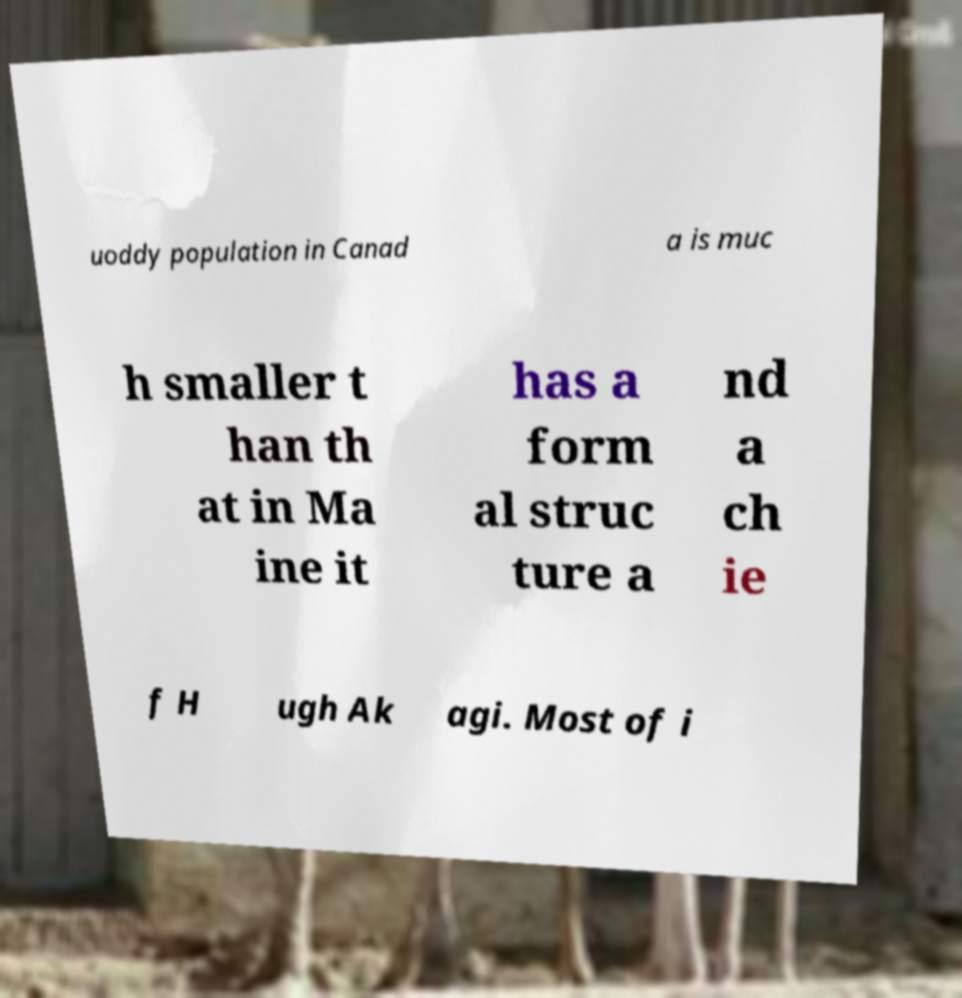I need the written content from this picture converted into text. Can you do that? uoddy population in Canad a is muc h smaller t han th at in Ma ine it has a form al struc ture a nd a ch ie f H ugh Ak agi. Most of i 